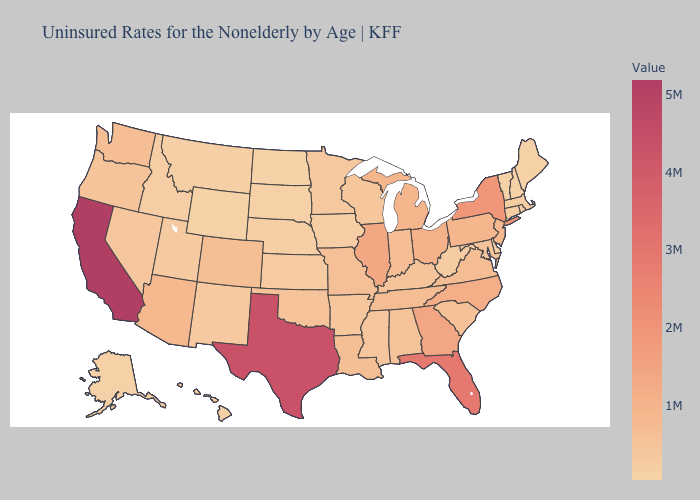Is the legend a continuous bar?
Short answer required. Yes. Does North Carolina have the highest value in the USA?
Give a very brief answer. No. Does Nevada have the lowest value in the USA?
Concise answer only. No. Which states have the highest value in the USA?
Concise answer only. California. Does Delaware have the lowest value in the South?
Give a very brief answer. Yes. Does Oregon have a higher value than Florida?
Quick response, please. No. 